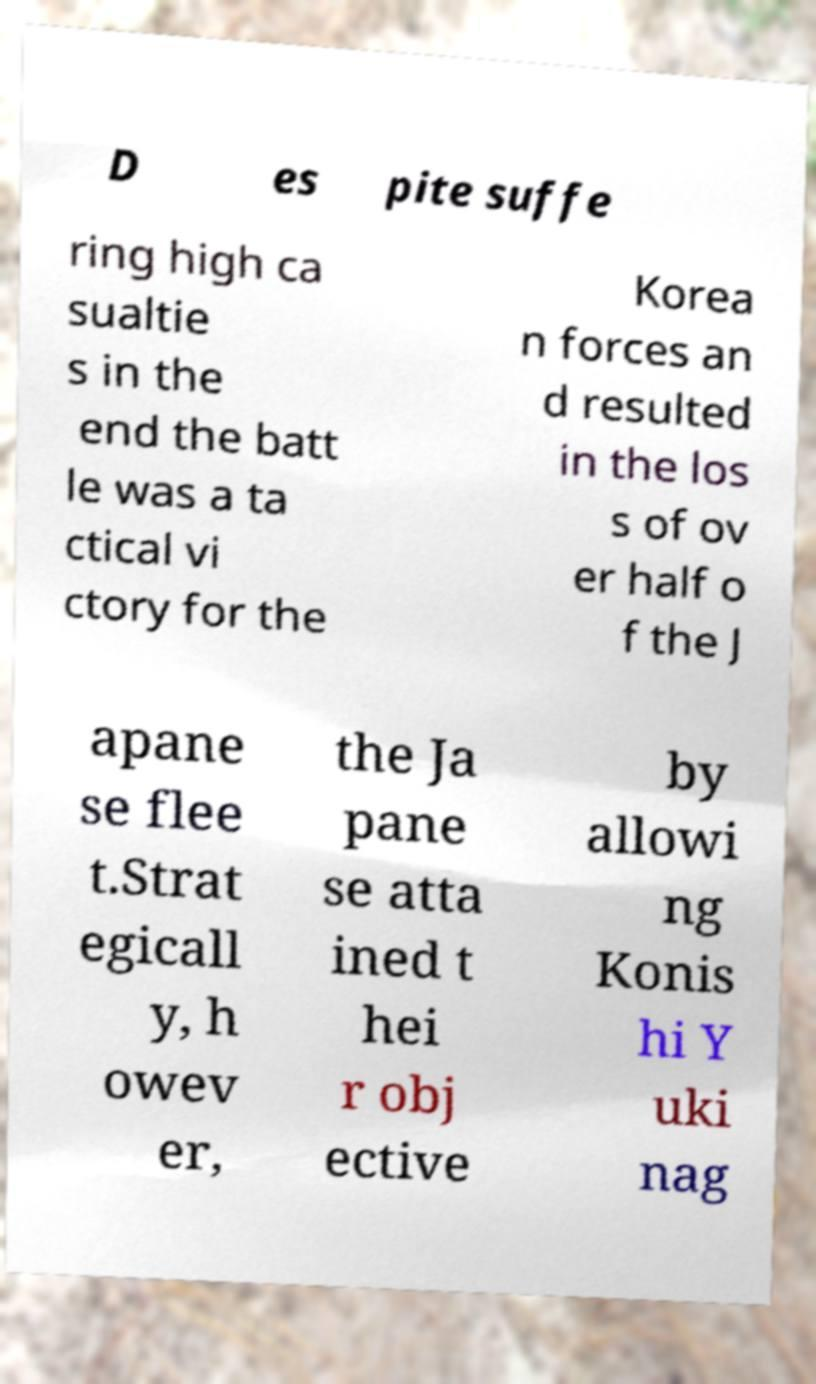For documentation purposes, I need the text within this image transcribed. Could you provide that? D es pite suffe ring high ca sualtie s in the end the batt le was a ta ctical vi ctory for the Korea n forces an d resulted in the los s of ov er half o f the J apane se flee t.Strat egicall y, h owev er, the Ja pane se atta ined t hei r obj ective by allowi ng Konis hi Y uki nag 